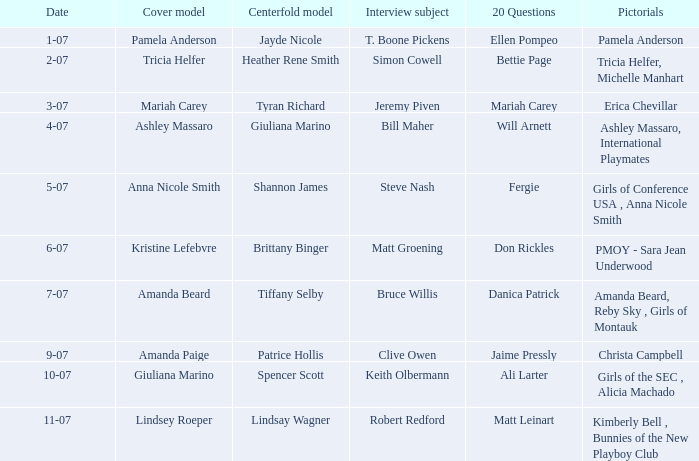When lindsey roeper was on the cover, what were the pictorials in those issues? Kimberly Bell , Bunnies of the New Playboy Club. 